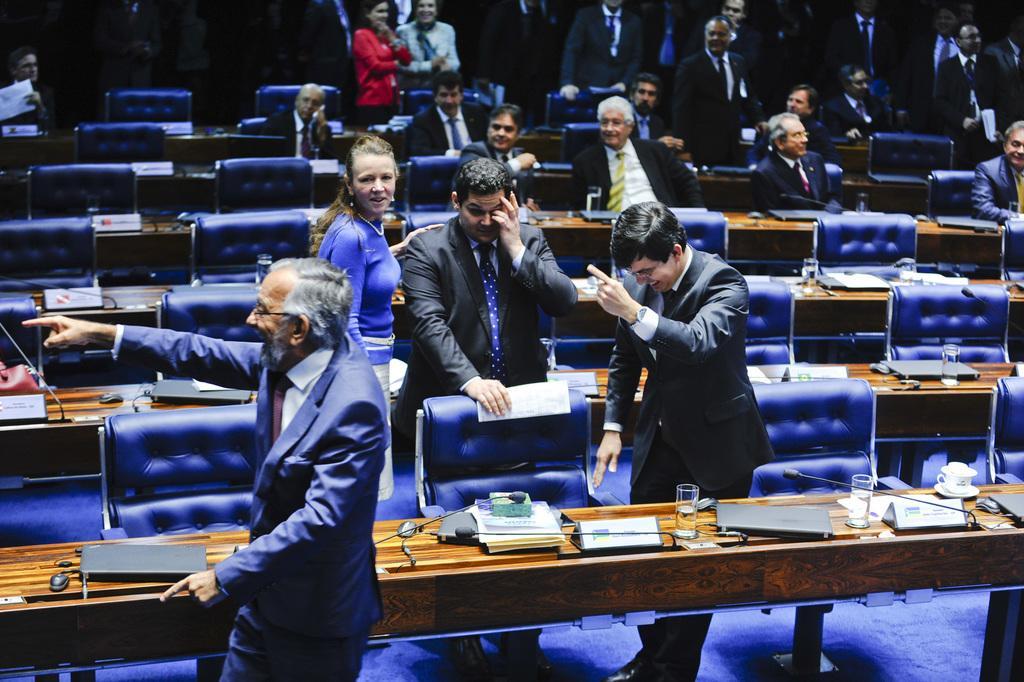How would you summarize this image in a sentence or two? In the image few people are standing and sitting. Behind them there are some tables, on the tables there are some glasses and papers and books and mouses and laptops and microphones. Behind them there are some chairs. 